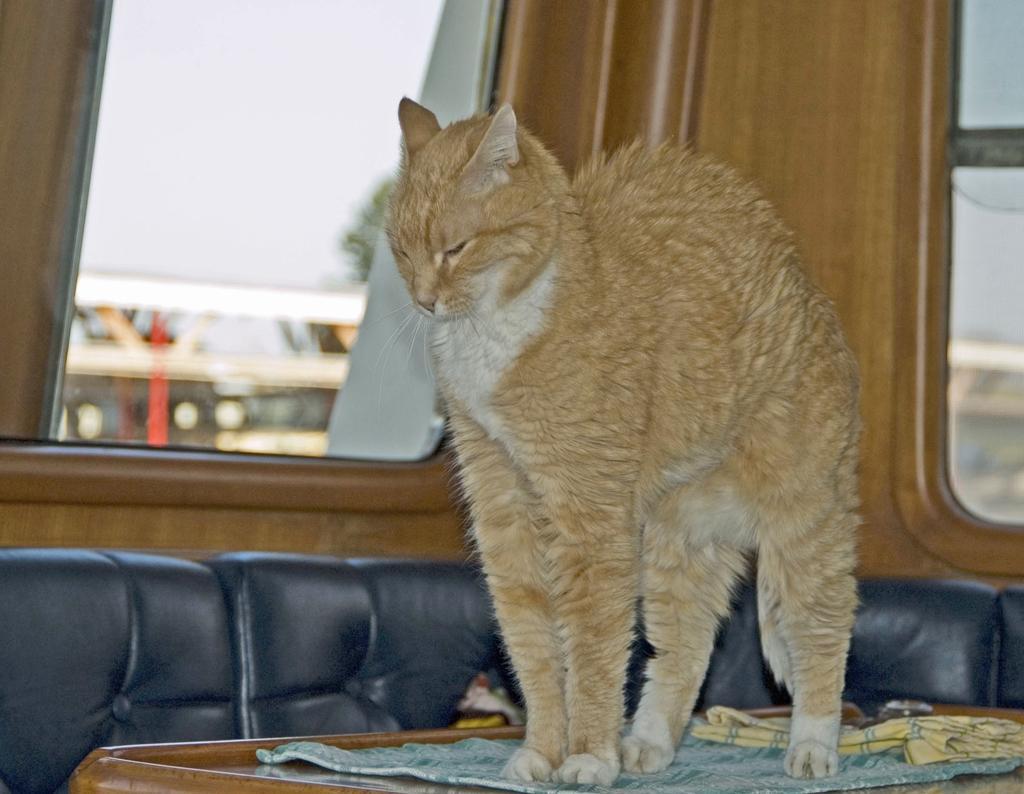What type of animal is in the image? There is a cat in the image. Where is the cat standing in the image? The cat is standing on a wooden table. What else can be seen in the image besides the cat? The cat is standing near a window. What team does the cat belong to in the image? There is no team or any indication of team affiliation in the image; it simply features a cat standing on a wooden table near a window. 